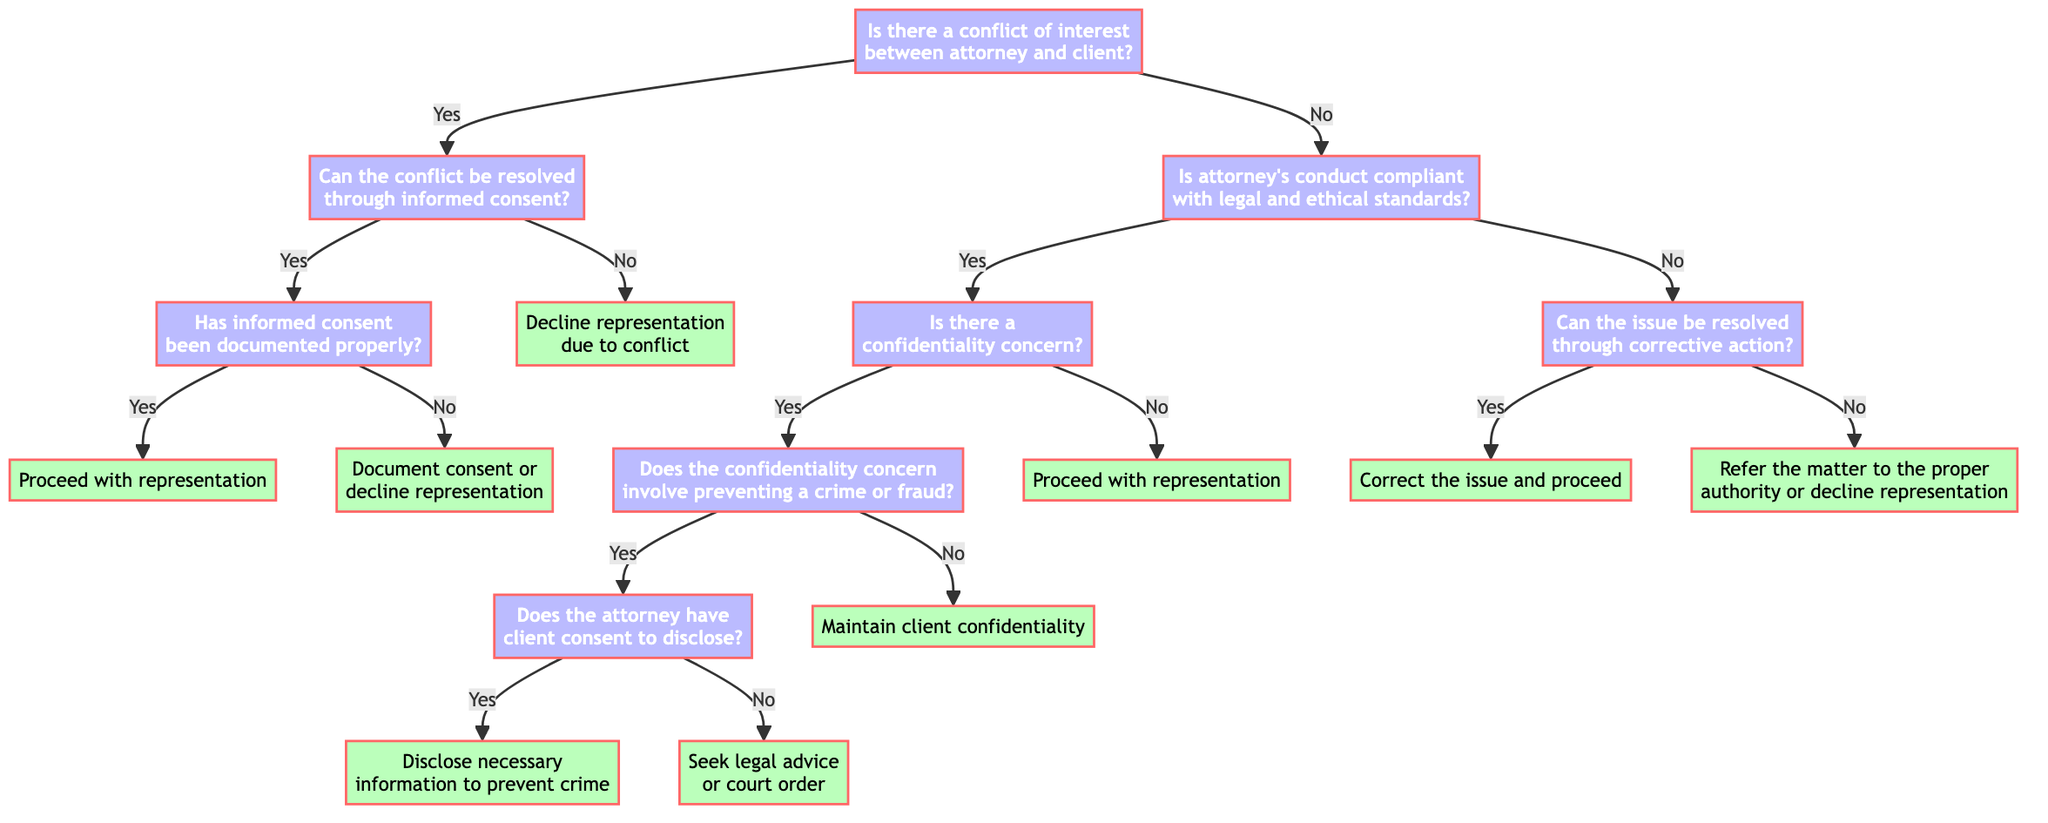What is the first question in the decision tree? The first question, which is located at the root of the decision tree, asks about the presence of a conflict of interest between the attorney and the client.
Answer: Is there a conflict of interest between the attorney and the client? What happens if there is a conflict of interest? If there is a conflict of interest, the next question is whether the conflict can be resolved through informed consent from both parties.
Answer: Can the conflict be resolved through informed consent of both parties? How many outcomes are there if a conflict is resolved through informed consent? If the conflict is resolved through informed consent, there are two possible outcomes depending on whether the informed consent has been documented properly or not.
Answer: Two outcomes What should an attorney do if there is no conflict of interest and the attorney's conduct is not compliant with legal and ethical standards? If there is no conflict of interest and the attorney's conduct is not compliant with standards, the next question is whether the issue can be resolved through corrective action. If not, the attorney should refer the matter to the proper authority or decline representation.
Answer: Refer the matter to the proper authority or decline representation If there is a confidentiality concern involving preventing a crime, what is the next question? If there is a confidentiality concern that involves preventing a crime or fraud, the next question is whether the attorney has client consent to disclose necessary information.
Answer: Does the attorney have client consent to disclose? What should the attorney do if the confidentiality concern does not involve preventing a crime or fraud? If the confidentiality concern does not involve preventing a crime or fraud, the attorney should maintain client confidentiality and not disclose any information.
Answer: Maintain client confidentiality What action should be taken if the informed consent has not been documented properly? If informed consent has not been documented properly, the attorney should either document the consent or decline representation.
Answer: Document consent or decline representation What is the outcome if the attorney's conduct is compliant and there is no confidentiality concern? If the attorney's conduct is compliant with legal and ethical standards and there is no confidentiality concern, the attorney can proceed with representation.
Answer: Proceed with representation What does the diagram suggest if corrective action can resolve the attorney's compliance issue? If the attorney can resolve compliance issues through corrective action, the next step is to correct the issue and proceed with representation.
Answer: Correct the issue and proceed 